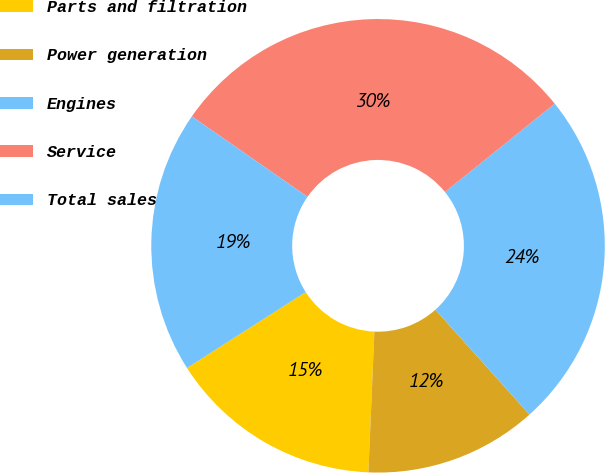Convert chart. <chart><loc_0><loc_0><loc_500><loc_500><pie_chart><fcel>Parts and filtration<fcel>Power generation<fcel>Engines<fcel>Service<fcel>Total sales<nl><fcel>15.27%<fcel>12.32%<fcel>24.14%<fcel>29.56%<fcel>18.72%<nl></chart> 